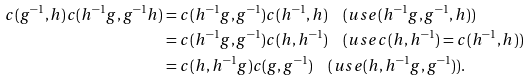<formula> <loc_0><loc_0><loc_500><loc_500>c ( g ^ { - 1 } , h ) c ( h ^ { - 1 } g , g ^ { - 1 } h ) & = c ( h ^ { - 1 } g , g ^ { - 1 } ) c ( h ^ { - 1 } , h ) \quad ( u s e ( h ^ { - 1 } g , g ^ { - 1 } , h ) ) \\ & = c ( h ^ { - 1 } g , g ^ { - 1 } ) c ( h , h ^ { - 1 } ) \quad ( u s e c ( h , h ^ { - 1 } ) = c ( h ^ { - 1 } , h ) ) \\ & = c ( h , h ^ { - 1 } g ) c ( g , g ^ { - 1 } ) \quad ( u s e ( h , h ^ { - 1 } g , g ^ { - 1 } ) ) .</formula> 